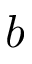<formula> <loc_0><loc_0><loc_500><loc_500>b</formula> 